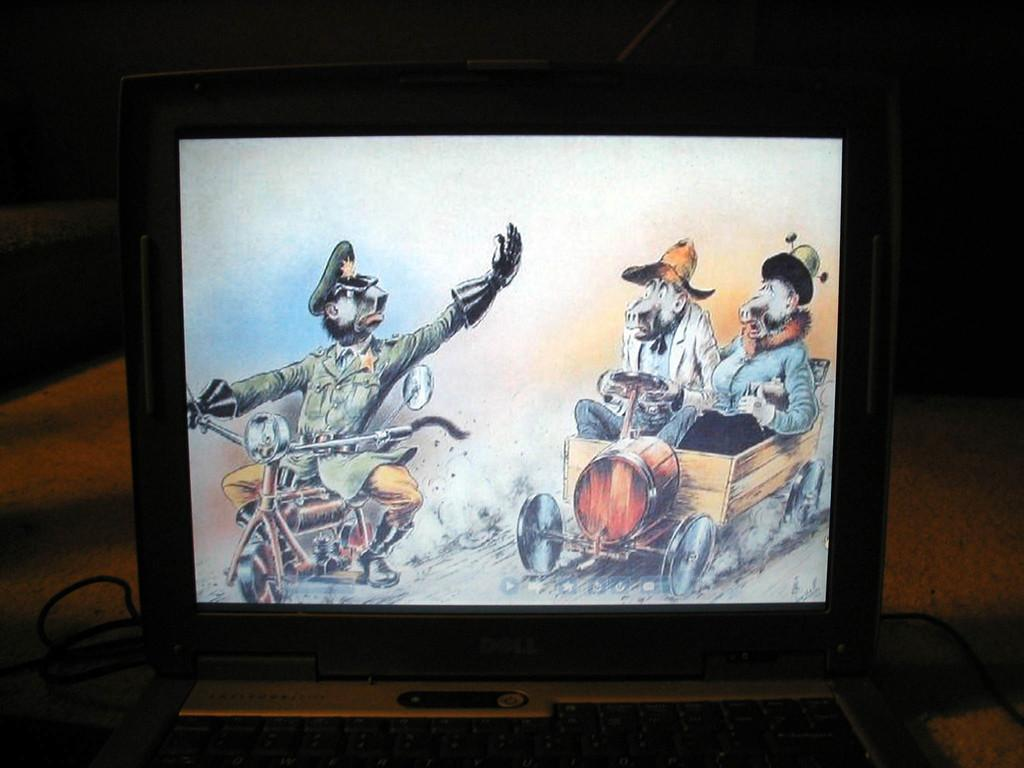<image>
Present a compact description of the photo's key features. A dell laptops its in a dark room with a movie being played 